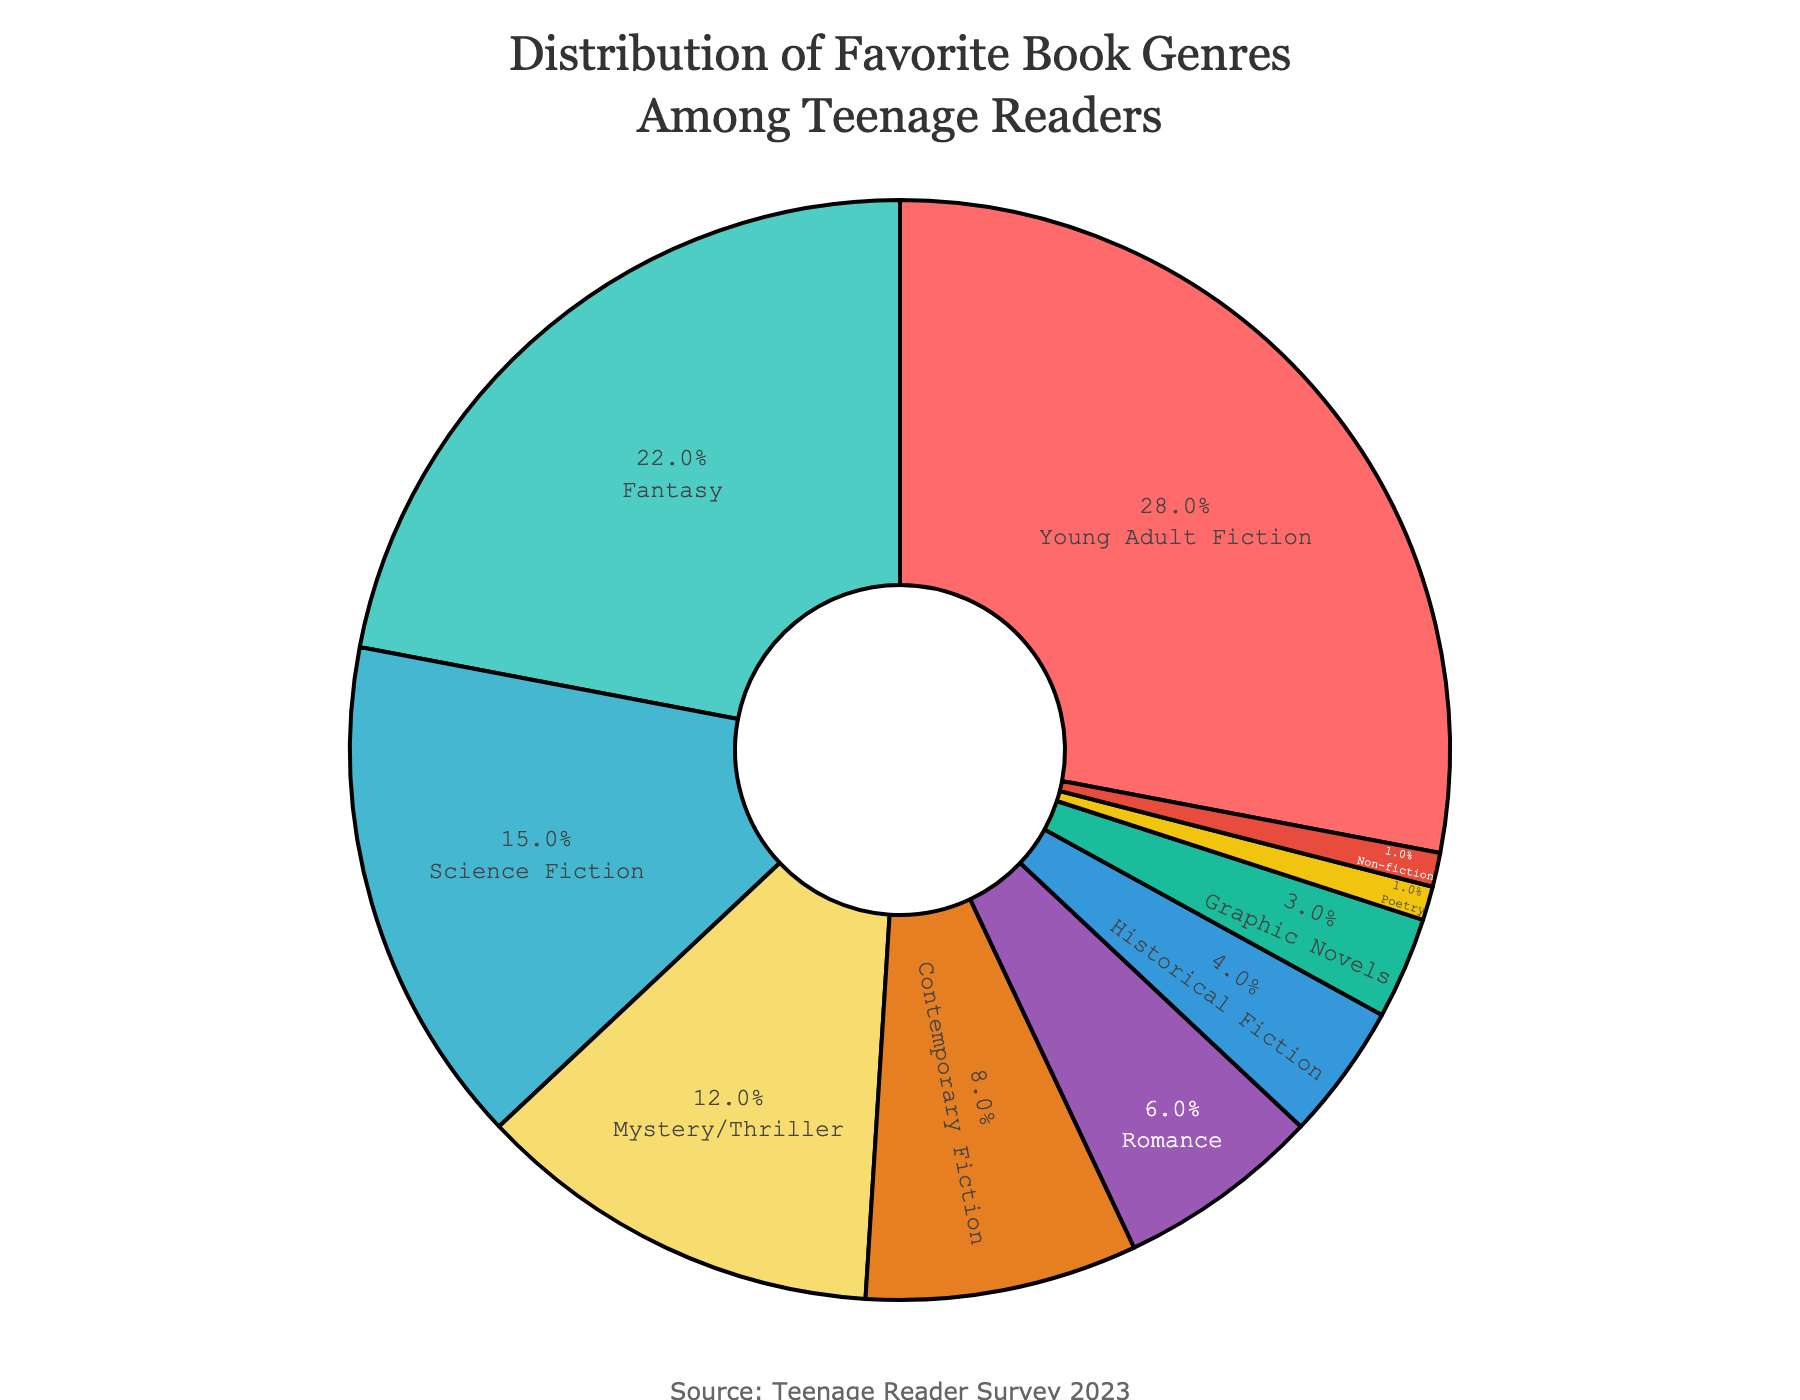Which genre has the highest percentage among teenage readers? The largest segment in the pie chart belongs to Young Adult Fiction, which has a percentage of 28%. This is shown with the biggest slice in the chart.
Answer: Young Adult Fiction What is the combined percentage of Romance and Historical Fiction? The pie chart shows Romance at 6% and Historical Fiction at 4%. Adding these percentages, we get 6% + 4% = 10%.
Answer: 10% Which genre has a lower percentage: Science Fiction or Mystery/Thriller? Looking at the pie chart, Science Fiction has a percentage of 15%, while Mystery/Thriller has a percentage of 12%. Since 12% is lower than 15%, Mystery/Thriller has a lower percentage.
Answer: Mystery/Thriller How much larger is the percentage of Fantasy compared to Poetry? Fantasy is 22% while Poetry is 1%. The difference between these percentages is 22% - 1% = 21%.
Answer: 21% If you combine the percentages of Graphic Novels, Poetry, and Non-fiction, what do you get? The pie chart shows Graphic Novels at 3%, Poetry at 1%, and Non-fiction at 1%. Summing these, we get 3% + 1% + 1% = 5%.
Answer: 5% Which three genres have the smallest combined percentage? The genres with the smallest percentages are Poetry (1%), Non-fiction (1%), and Graphic Novels (3%). Adding these, 1% + 1% + 3% = 5%.
Answer: Poetry, Non-fiction, Graphic Novels Is the percentage of Mystery/Thriller more than double that of Romance? Mystery/Thriller has a percentage of 12%, and Romance has a percentage of 6%. Since 12% is exactly double 6%, Mystery/Thriller is not more than double Romance.
Answer: No Comparing Contemporary Fiction and Non-fiction, which one is more popular, and by how much? Contemporary Fiction has a percentage of 8%, while Non-fiction has a percentage of 1%. The difference between these percentages is 8% - 1% = 7%, so Contemporary Fiction is more popular by 7%.
Answer: Contemporary Fiction by 7% Are there any genres that have the same percentage? The pie chart shows that both Poetry and Non-fiction have a percentage of 1%. These are the only genres with the same percentage in the chart.
Answer: Yes, Poetry and Non-fiction What is the total percentage for Young Adult Fiction, Fantasy, and Science Fiction combined? Young Adult Fiction is 28%, Fantasy is 22%, and Science Fiction is 15%. Adding these, 28% + 22% + 15% = 65%.
Answer: 65% 